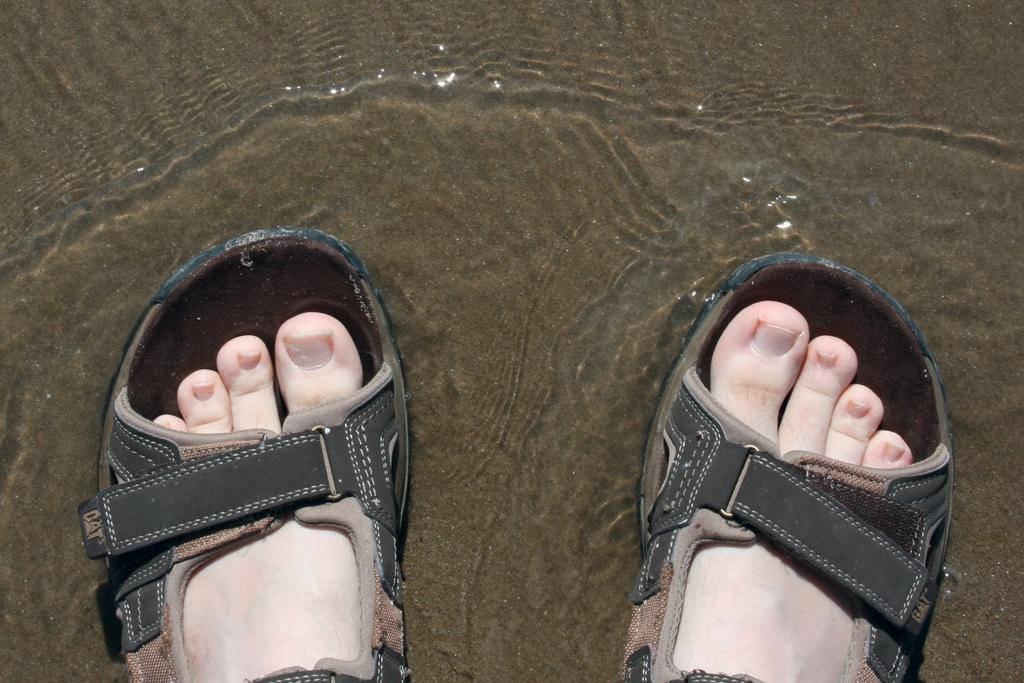Who or what is present in the image? There is a person in the image. What is the person doing in the image? The person is standing in the water. What type of footwear is the person wearing? The person is wearing sandals. What type of garden can be seen in the image? There is no garden present in the image; it features a person standing in the water while wearing sandals. 